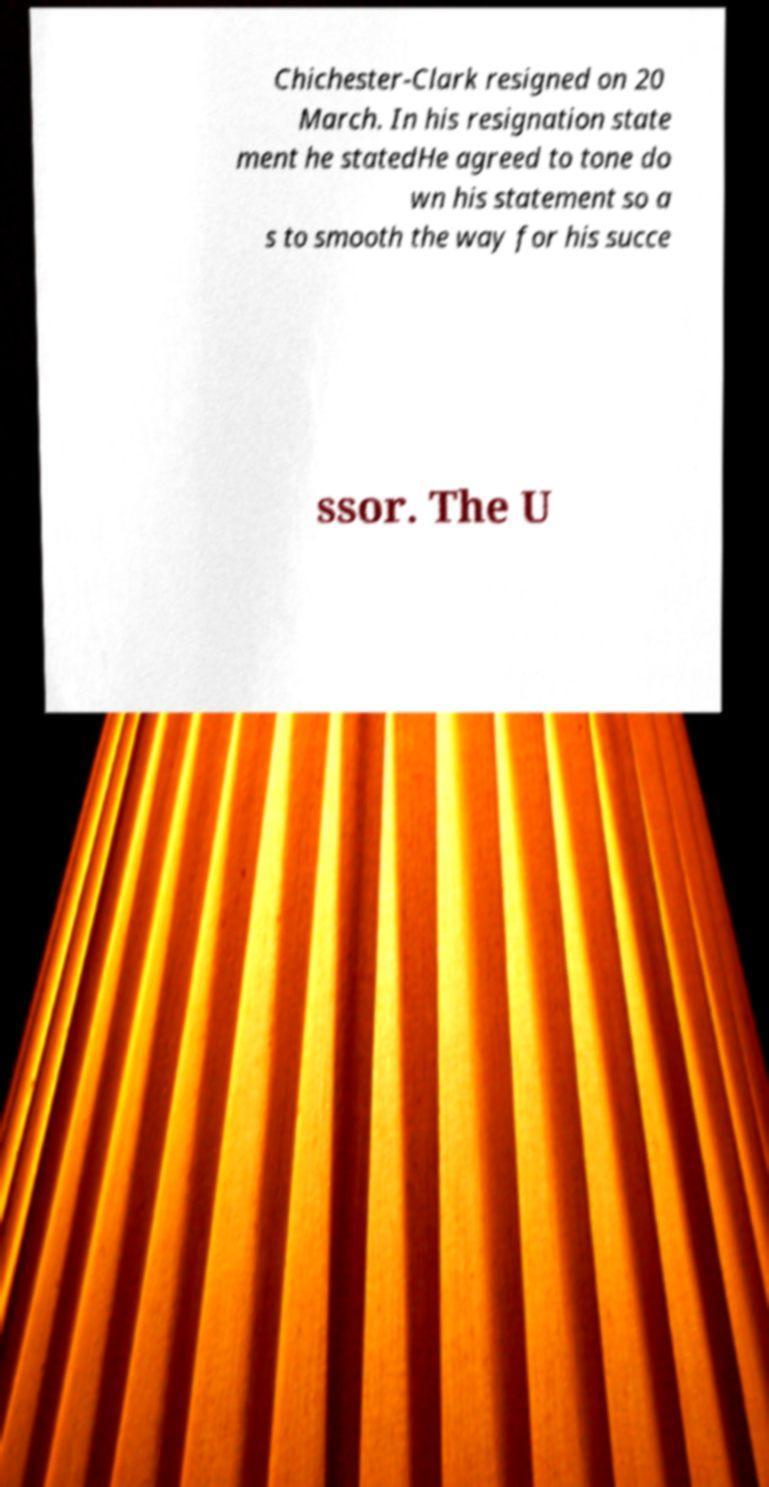Can you read and provide the text displayed in the image?This photo seems to have some interesting text. Can you extract and type it out for me? Chichester-Clark resigned on 20 March. In his resignation state ment he statedHe agreed to tone do wn his statement so a s to smooth the way for his succe ssor. The U 